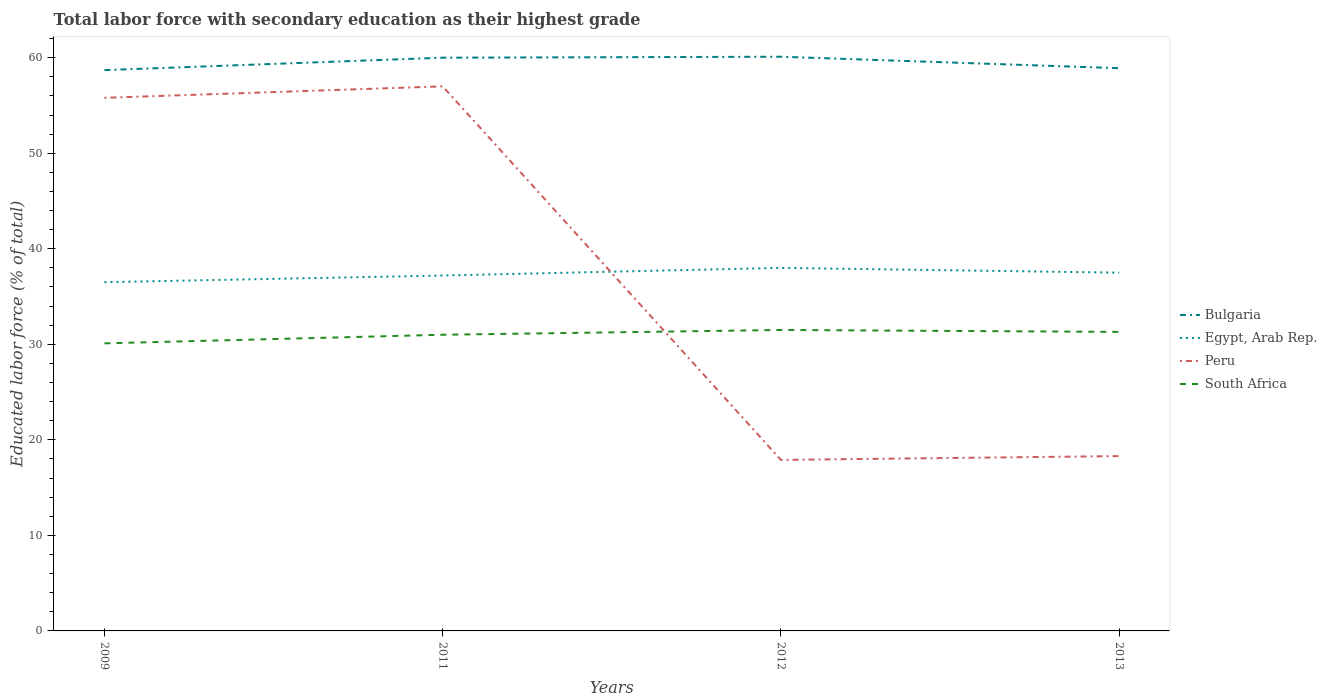How many different coloured lines are there?
Offer a terse response. 4. Does the line corresponding to Bulgaria intersect with the line corresponding to South Africa?
Offer a very short reply. No. Is the number of lines equal to the number of legend labels?
Your answer should be compact. Yes. Across all years, what is the maximum percentage of total labor force with primary education in Egypt, Arab Rep.?
Your response must be concise. 36.5. In which year was the percentage of total labor force with primary education in Bulgaria maximum?
Your response must be concise. 2009. What is the total percentage of total labor force with primary education in South Africa in the graph?
Provide a succinct answer. 0.2. What is the difference between the highest and the second highest percentage of total labor force with primary education in Bulgaria?
Your answer should be compact. 1.4. What is the difference between the highest and the lowest percentage of total labor force with primary education in Peru?
Keep it short and to the point. 2. How many lines are there?
Give a very brief answer. 4. Does the graph contain grids?
Ensure brevity in your answer.  No. Where does the legend appear in the graph?
Offer a terse response. Center right. How many legend labels are there?
Your answer should be very brief. 4. What is the title of the graph?
Keep it short and to the point. Total labor force with secondary education as their highest grade. What is the label or title of the X-axis?
Ensure brevity in your answer.  Years. What is the label or title of the Y-axis?
Your answer should be compact. Educated labor force (% of total). What is the Educated labor force (% of total) of Bulgaria in 2009?
Your answer should be compact. 58.7. What is the Educated labor force (% of total) in Egypt, Arab Rep. in 2009?
Keep it short and to the point. 36.5. What is the Educated labor force (% of total) in Peru in 2009?
Your response must be concise. 55.8. What is the Educated labor force (% of total) of South Africa in 2009?
Make the answer very short. 30.1. What is the Educated labor force (% of total) in Egypt, Arab Rep. in 2011?
Make the answer very short. 37.2. What is the Educated labor force (% of total) in Peru in 2011?
Make the answer very short. 57. What is the Educated labor force (% of total) in Bulgaria in 2012?
Offer a terse response. 60.1. What is the Educated labor force (% of total) of Peru in 2012?
Offer a very short reply. 17.9. What is the Educated labor force (% of total) in South Africa in 2012?
Offer a terse response. 31.5. What is the Educated labor force (% of total) in Bulgaria in 2013?
Provide a short and direct response. 58.9. What is the Educated labor force (% of total) of Egypt, Arab Rep. in 2013?
Your response must be concise. 37.5. What is the Educated labor force (% of total) in Peru in 2013?
Ensure brevity in your answer.  18.3. What is the Educated labor force (% of total) of South Africa in 2013?
Offer a terse response. 31.3. Across all years, what is the maximum Educated labor force (% of total) of Bulgaria?
Offer a very short reply. 60.1. Across all years, what is the maximum Educated labor force (% of total) in Peru?
Your answer should be compact. 57. Across all years, what is the maximum Educated labor force (% of total) of South Africa?
Your answer should be very brief. 31.5. Across all years, what is the minimum Educated labor force (% of total) in Bulgaria?
Your answer should be compact. 58.7. Across all years, what is the minimum Educated labor force (% of total) in Egypt, Arab Rep.?
Offer a very short reply. 36.5. Across all years, what is the minimum Educated labor force (% of total) of Peru?
Make the answer very short. 17.9. Across all years, what is the minimum Educated labor force (% of total) in South Africa?
Provide a succinct answer. 30.1. What is the total Educated labor force (% of total) of Bulgaria in the graph?
Provide a short and direct response. 237.7. What is the total Educated labor force (% of total) of Egypt, Arab Rep. in the graph?
Offer a very short reply. 149.2. What is the total Educated labor force (% of total) of Peru in the graph?
Provide a short and direct response. 149. What is the total Educated labor force (% of total) of South Africa in the graph?
Make the answer very short. 123.9. What is the difference between the Educated labor force (% of total) in South Africa in 2009 and that in 2011?
Offer a terse response. -0.9. What is the difference between the Educated labor force (% of total) of Egypt, Arab Rep. in 2009 and that in 2012?
Your answer should be very brief. -1.5. What is the difference between the Educated labor force (% of total) in Peru in 2009 and that in 2012?
Your response must be concise. 37.9. What is the difference between the Educated labor force (% of total) in Bulgaria in 2009 and that in 2013?
Offer a terse response. -0.2. What is the difference between the Educated labor force (% of total) in Peru in 2009 and that in 2013?
Your response must be concise. 37.5. What is the difference between the Educated labor force (% of total) of Bulgaria in 2011 and that in 2012?
Provide a short and direct response. -0.1. What is the difference between the Educated labor force (% of total) in Peru in 2011 and that in 2012?
Ensure brevity in your answer.  39.1. What is the difference between the Educated labor force (% of total) in South Africa in 2011 and that in 2012?
Ensure brevity in your answer.  -0.5. What is the difference between the Educated labor force (% of total) in Bulgaria in 2011 and that in 2013?
Offer a very short reply. 1.1. What is the difference between the Educated labor force (% of total) in Peru in 2011 and that in 2013?
Offer a very short reply. 38.7. What is the difference between the Educated labor force (% of total) in South Africa in 2011 and that in 2013?
Provide a succinct answer. -0.3. What is the difference between the Educated labor force (% of total) in Peru in 2012 and that in 2013?
Make the answer very short. -0.4. What is the difference between the Educated labor force (% of total) in South Africa in 2012 and that in 2013?
Your answer should be compact. 0.2. What is the difference between the Educated labor force (% of total) in Bulgaria in 2009 and the Educated labor force (% of total) in Egypt, Arab Rep. in 2011?
Your response must be concise. 21.5. What is the difference between the Educated labor force (% of total) in Bulgaria in 2009 and the Educated labor force (% of total) in South Africa in 2011?
Keep it short and to the point. 27.7. What is the difference between the Educated labor force (% of total) in Egypt, Arab Rep. in 2009 and the Educated labor force (% of total) in Peru in 2011?
Offer a terse response. -20.5. What is the difference between the Educated labor force (% of total) of Peru in 2009 and the Educated labor force (% of total) of South Africa in 2011?
Ensure brevity in your answer.  24.8. What is the difference between the Educated labor force (% of total) of Bulgaria in 2009 and the Educated labor force (% of total) of Egypt, Arab Rep. in 2012?
Ensure brevity in your answer.  20.7. What is the difference between the Educated labor force (% of total) of Bulgaria in 2009 and the Educated labor force (% of total) of Peru in 2012?
Your answer should be compact. 40.8. What is the difference between the Educated labor force (% of total) in Bulgaria in 2009 and the Educated labor force (% of total) in South Africa in 2012?
Make the answer very short. 27.2. What is the difference between the Educated labor force (% of total) in Egypt, Arab Rep. in 2009 and the Educated labor force (% of total) in Peru in 2012?
Provide a short and direct response. 18.6. What is the difference between the Educated labor force (% of total) in Egypt, Arab Rep. in 2009 and the Educated labor force (% of total) in South Africa in 2012?
Keep it short and to the point. 5. What is the difference between the Educated labor force (% of total) in Peru in 2009 and the Educated labor force (% of total) in South Africa in 2012?
Make the answer very short. 24.3. What is the difference between the Educated labor force (% of total) in Bulgaria in 2009 and the Educated labor force (% of total) in Egypt, Arab Rep. in 2013?
Give a very brief answer. 21.2. What is the difference between the Educated labor force (% of total) of Bulgaria in 2009 and the Educated labor force (% of total) of Peru in 2013?
Provide a succinct answer. 40.4. What is the difference between the Educated labor force (% of total) in Bulgaria in 2009 and the Educated labor force (% of total) in South Africa in 2013?
Your answer should be very brief. 27.4. What is the difference between the Educated labor force (% of total) of Peru in 2009 and the Educated labor force (% of total) of South Africa in 2013?
Your response must be concise. 24.5. What is the difference between the Educated labor force (% of total) in Bulgaria in 2011 and the Educated labor force (% of total) in Peru in 2012?
Offer a very short reply. 42.1. What is the difference between the Educated labor force (% of total) of Bulgaria in 2011 and the Educated labor force (% of total) of South Africa in 2012?
Give a very brief answer. 28.5. What is the difference between the Educated labor force (% of total) in Egypt, Arab Rep. in 2011 and the Educated labor force (% of total) in Peru in 2012?
Give a very brief answer. 19.3. What is the difference between the Educated labor force (% of total) of Egypt, Arab Rep. in 2011 and the Educated labor force (% of total) of South Africa in 2012?
Your response must be concise. 5.7. What is the difference between the Educated labor force (% of total) in Peru in 2011 and the Educated labor force (% of total) in South Africa in 2012?
Your response must be concise. 25.5. What is the difference between the Educated labor force (% of total) in Bulgaria in 2011 and the Educated labor force (% of total) in Egypt, Arab Rep. in 2013?
Provide a short and direct response. 22.5. What is the difference between the Educated labor force (% of total) in Bulgaria in 2011 and the Educated labor force (% of total) in Peru in 2013?
Provide a short and direct response. 41.7. What is the difference between the Educated labor force (% of total) of Bulgaria in 2011 and the Educated labor force (% of total) of South Africa in 2013?
Your answer should be very brief. 28.7. What is the difference between the Educated labor force (% of total) of Egypt, Arab Rep. in 2011 and the Educated labor force (% of total) of Peru in 2013?
Provide a short and direct response. 18.9. What is the difference between the Educated labor force (% of total) of Egypt, Arab Rep. in 2011 and the Educated labor force (% of total) of South Africa in 2013?
Your response must be concise. 5.9. What is the difference between the Educated labor force (% of total) of Peru in 2011 and the Educated labor force (% of total) of South Africa in 2013?
Offer a very short reply. 25.7. What is the difference between the Educated labor force (% of total) of Bulgaria in 2012 and the Educated labor force (% of total) of Egypt, Arab Rep. in 2013?
Ensure brevity in your answer.  22.6. What is the difference between the Educated labor force (% of total) in Bulgaria in 2012 and the Educated labor force (% of total) in Peru in 2013?
Offer a terse response. 41.8. What is the difference between the Educated labor force (% of total) of Bulgaria in 2012 and the Educated labor force (% of total) of South Africa in 2013?
Your answer should be compact. 28.8. What is the difference between the Educated labor force (% of total) in Egypt, Arab Rep. in 2012 and the Educated labor force (% of total) in Peru in 2013?
Provide a short and direct response. 19.7. What is the difference between the Educated labor force (% of total) of Peru in 2012 and the Educated labor force (% of total) of South Africa in 2013?
Keep it short and to the point. -13.4. What is the average Educated labor force (% of total) of Bulgaria per year?
Your response must be concise. 59.42. What is the average Educated labor force (% of total) of Egypt, Arab Rep. per year?
Make the answer very short. 37.3. What is the average Educated labor force (% of total) of Peru per year?
Your answer should be compact. 37.25. What is the average Educated labor force (% of total) of South Africa per year?
Offer a very short reply. 30.98. In the year 2009, what is the difference between the Educated labor force (% of total) in Bulgaria and Educated labor force (% of total) in South Africa?
Provide a succinct answer. 28.6. In the year 2009, what is the difference between the Educated labor force (% of total) in Egypt, Arab Rep. and Educated labor force (% of total) in Peru?
Provide a succinct answer. -19.3. In the year 2009, what is the difference between the Educated labor force (% of total) in Peru and Educated labor force (% of total) in South Africa?
Make the answer very short. 25.7. In the year 2011, what is the difference between the Educated labor force (% of total) in Bulgaria and Educated labor force (% of total) in Egypt, Arab Rep.?
Provide a succinct answer. 22.8. In the year 2011, what is the difference between the Educated labor force (% of total) in Bulgaria and Educated labor force (% of total) in Peru?
Give a very brief answer. 3. In the year 2011, what is the difference between the Educated labor force (% of total) of Bulgaria and Educated labor force (% of total) of South Africa?
Provide a succinct answer. 29. In the year 2011, what is the difference between the Educated labor force (% of total) in Egypt, Arab Rep. and Educated labor force (% of total) in Peru?
Keep it short and to the point. -19.8. In the year 2011, what is the difference between the Educated labor force (% of total) in Egypt, Arab Rep. and Educated labor force (% of total) in South Africa?
Provide a succinct answer. 6.2. In the year 2012, what is the difference between the Educated labor force (% of total) in Bulgaria and Educated labor force (% of total) in Egypt, Arab Rep.?
Your response must be concise. 22.1. In the year 2012, what is the difference between the Educated labor force (% of total) of Bulgaria and Educated labor force (% of total) of Peru?
Provide a succinct answer. 42.2. In the year 2012, what is the difference between the Educated labor force (% of total) of Bulgaria and Educated labor force (% of total) of South Africa?
Provide a succinct answer. 28.6. In the year 2012, what is the difference between the Educated labor force (% of total) of Egypt, Arab Rep. and Educated labor force (% of total) of Peru?
Give a very brief answer. 20.1. In the year 2012, what is the difference between the Educated labor force (% of total) of Egypt, Arab Rep. and Educated labor force (% of total) of South Africa?
Keep it short and to the point. 6.5. In the year 2012, what is the difference between the Educated labor force (% of total) in Peru and Educated labor force (% of total) in South Africa?
Your answer should be very brief. -13.6. In the year 2013, what is the difference between the Educated labor force (% of total) in Bulgaria and Educated labor force (% of total) in Egypt, Arab Rep.?
Offer a very short reply. 21.4. In the year 2013, what is the difference between the Educated labor force (% of total) in Bulgaria and Educated labor force (% of total) in Peru?
Your answer should be compact. 40.6. In the year 2013, what is the difference between the Educated labor force (% of total) of Bulgaria and Educated labor force (% of total) of South Africa?
Your answer should be compact. 27.6. In the year 2013, what is the difference between the Educated labor force (% of total) in Egypt, Arab Rep. and Educated labor force (% of total) in Peru?
Your answer should be very brief. 19.2. In the year 2013, what is the difference between the Educated labor force (% of total) of Egypt, Arab Rep. and Educated labor force (% of total) of South Africa?
Make the answer very short. 6.2. What is the ratio of the Educated labor force (% of total) in Bulgaria in 2009 to that in 2011?
Your response must be concise. 0.98. What is the ratio of the Educated labor force (% of total) of Egypt, Arab Rep. in 2009 to that in 2011?
Offer a terse response. 0.98. What is the ratio of the Educated labor force (% of total) of Peru in 2009 to that in 2011?
Keep it short and to the point. 0.98. What is the ratio of the Educated labor force (% of total) of Bulgaria in 2009 to that in 2012?
Give a very brief answer. 0.98. What is the ratio of the Educated labor force (% of total) in Egypt, Arab Rep. in 2009 to that in 2012?
Ensure brevity in your answer.  0.96. What is the ratio of the Educated labor force (% of total) in Peru in 2009 to that in 2012?
Keep it short and to the point. 3.12. What is the ratio of the Educated labor force (% of total) of South Africa in 2009 to that in 2012?
Offer a very short reply. 0.96. What is the ratio of the Educated labor force (% of total) in Bulgaria in 2009 to that in 2013?
Your response must be concise. 1. What is the ratio of the Educated labor force (% of total) in Egypt, Arab Rep. in 2009 to that in 2013?
Ensure brevity in your answer.  0.97. What is the ratio of the Educated labor force (% of total) of Peru in 2009 to that in 2013?
Provide a succinct answer. 3.05. What is the ratio of the Educated labor force (% of total) of South Africa in 2009 to that in 2013?
Offer a terse response. 0.96. What is the ratio of the Educated labor force (% of total) in Bulgaria in 2011 to that in 2012?
Provide a succinct answer. 1. What is the ratio of the Educated labor force (% of total) in Egypt, Arab Rep. in 2011 to that in 2012?
Your answer should be compact. 0.98. What is the ratio of the Educated labor force (% of total) of Peru in 2011 to that in 2012?
Give a very brief answer. 3.18. What is the ratio of the Educated labor force (% of total) of South Africa in 2011 to that in 2012?
Your answer should be very brief. 0.98. What is the ratio of the Educated labor force (% of total) of Bulgaria in 2011 to that in 2013?
Your answer should be very brief. 1.02. What is the ratio of the Educated labor force (% of total) in Peru in 2011 to that in 2013?
Keep it short and to the point. 3.11. What is the ratio of the Educated labor force (% of total) in South Africa in 2011 to that in 2013?
Give a very brief answer. 0.99. What is the ratio of the Educated labor force (% of total) of Bulgaria in 2012 to that in 2013?
Ensure brevity in your answer.  1.02. What is the ratio of the Educated labor force (% of total) of Egypt, Arab Rep. in 2012 to that in 2013?
Provide a succinct answer. 1.01. What is the ratio of the Educated labor force (% of total) of Peru in 2012 to that in 2013?
Make the answer very short. 0.98. What is the ratio of the Educated labor force (% of total) in South Africa in 2012 to that in 2013?
Provide a succinct answer. 1.01. What is the difference between the highest and the second highest Educated labor force (% of total) in Bulgaria?
Your answer should be compact. 0.1. What is the difference between the highest and the second highest Educated labor force (% of total) of Egypt, Arab Rep.?
Your answer should be very brief. 0.5. What is the difference between the highest and the second highest Educated labor force (% of total) in Peru?
Provide a short and direct response. 1.2. What is the difference between the highest and the lowest Educated labor force (% of total) in Peru?
Offer a very short reply. 39.1. What is the difference between the highest and the lowest Educated labor force (% of total) in South Africa?
Offer a terse response. 1.4. 